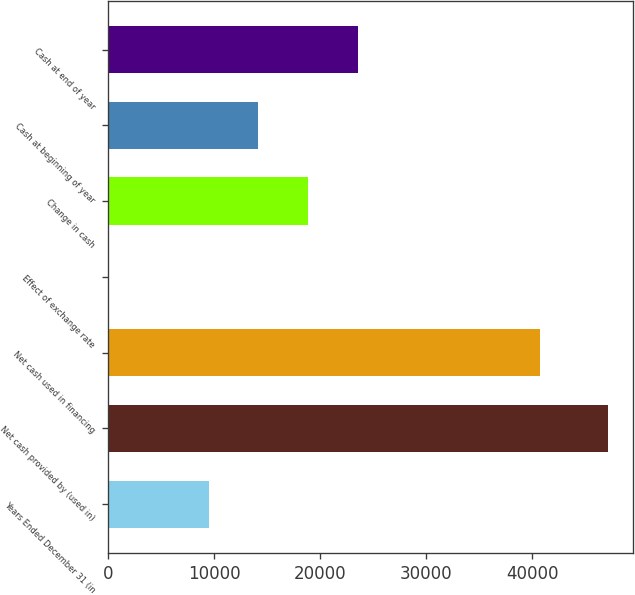Convert chart to OTSL. <chart><loc_0><loc_0><loc_500><loc_500><bar_chart><fcel>Years Ended December 31 (in<fcel>Net cash provided by (used in)<fcel>Net cash used in financing<fcel>Effect of exchange rate<fcel>Change in cash<fcel>Cash at beginning of year<fcel>Cash at end of year<nl><fcel>9465.6<fcel>47176<fcel>40734<fcel>38<fcel>18893.2<fcel>14179.4<fcel>23607<nl></chart> 